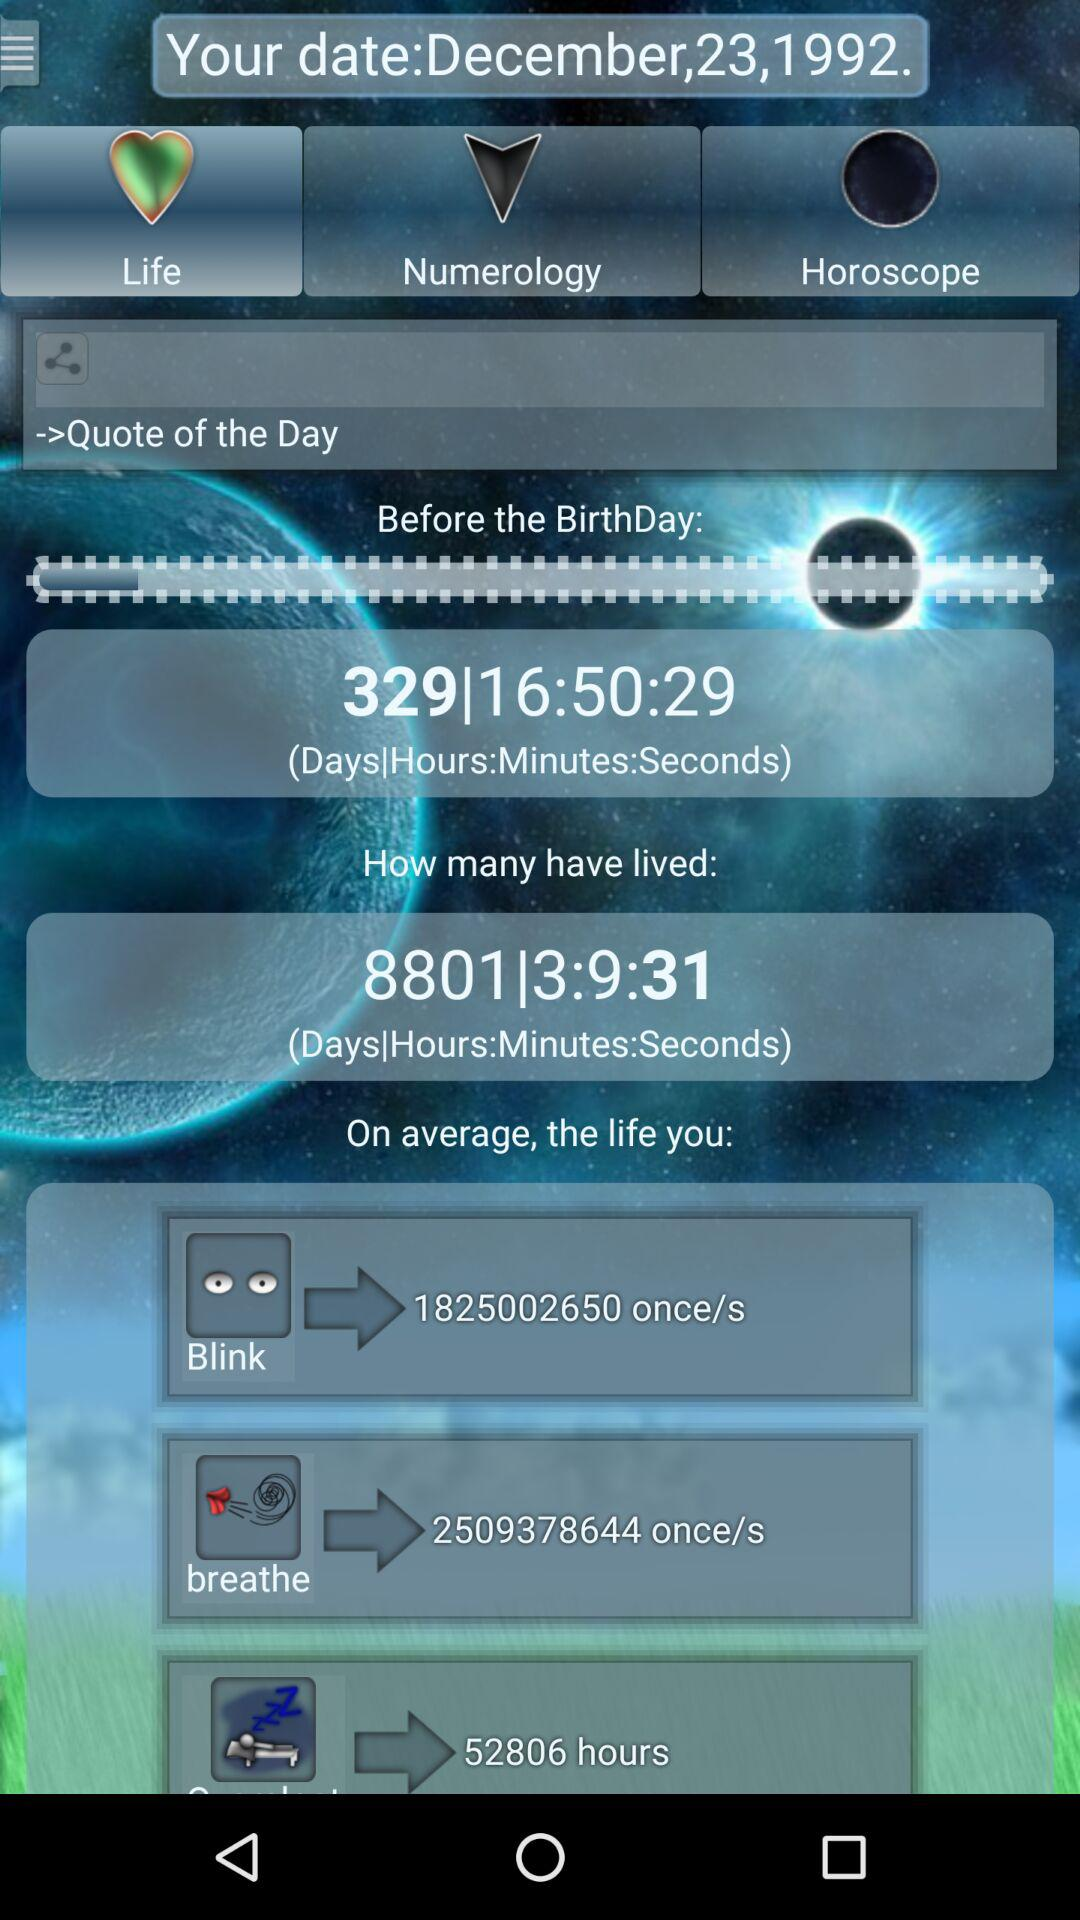What is the average breathe in life? The average breathe is 2509378644 once/s. 